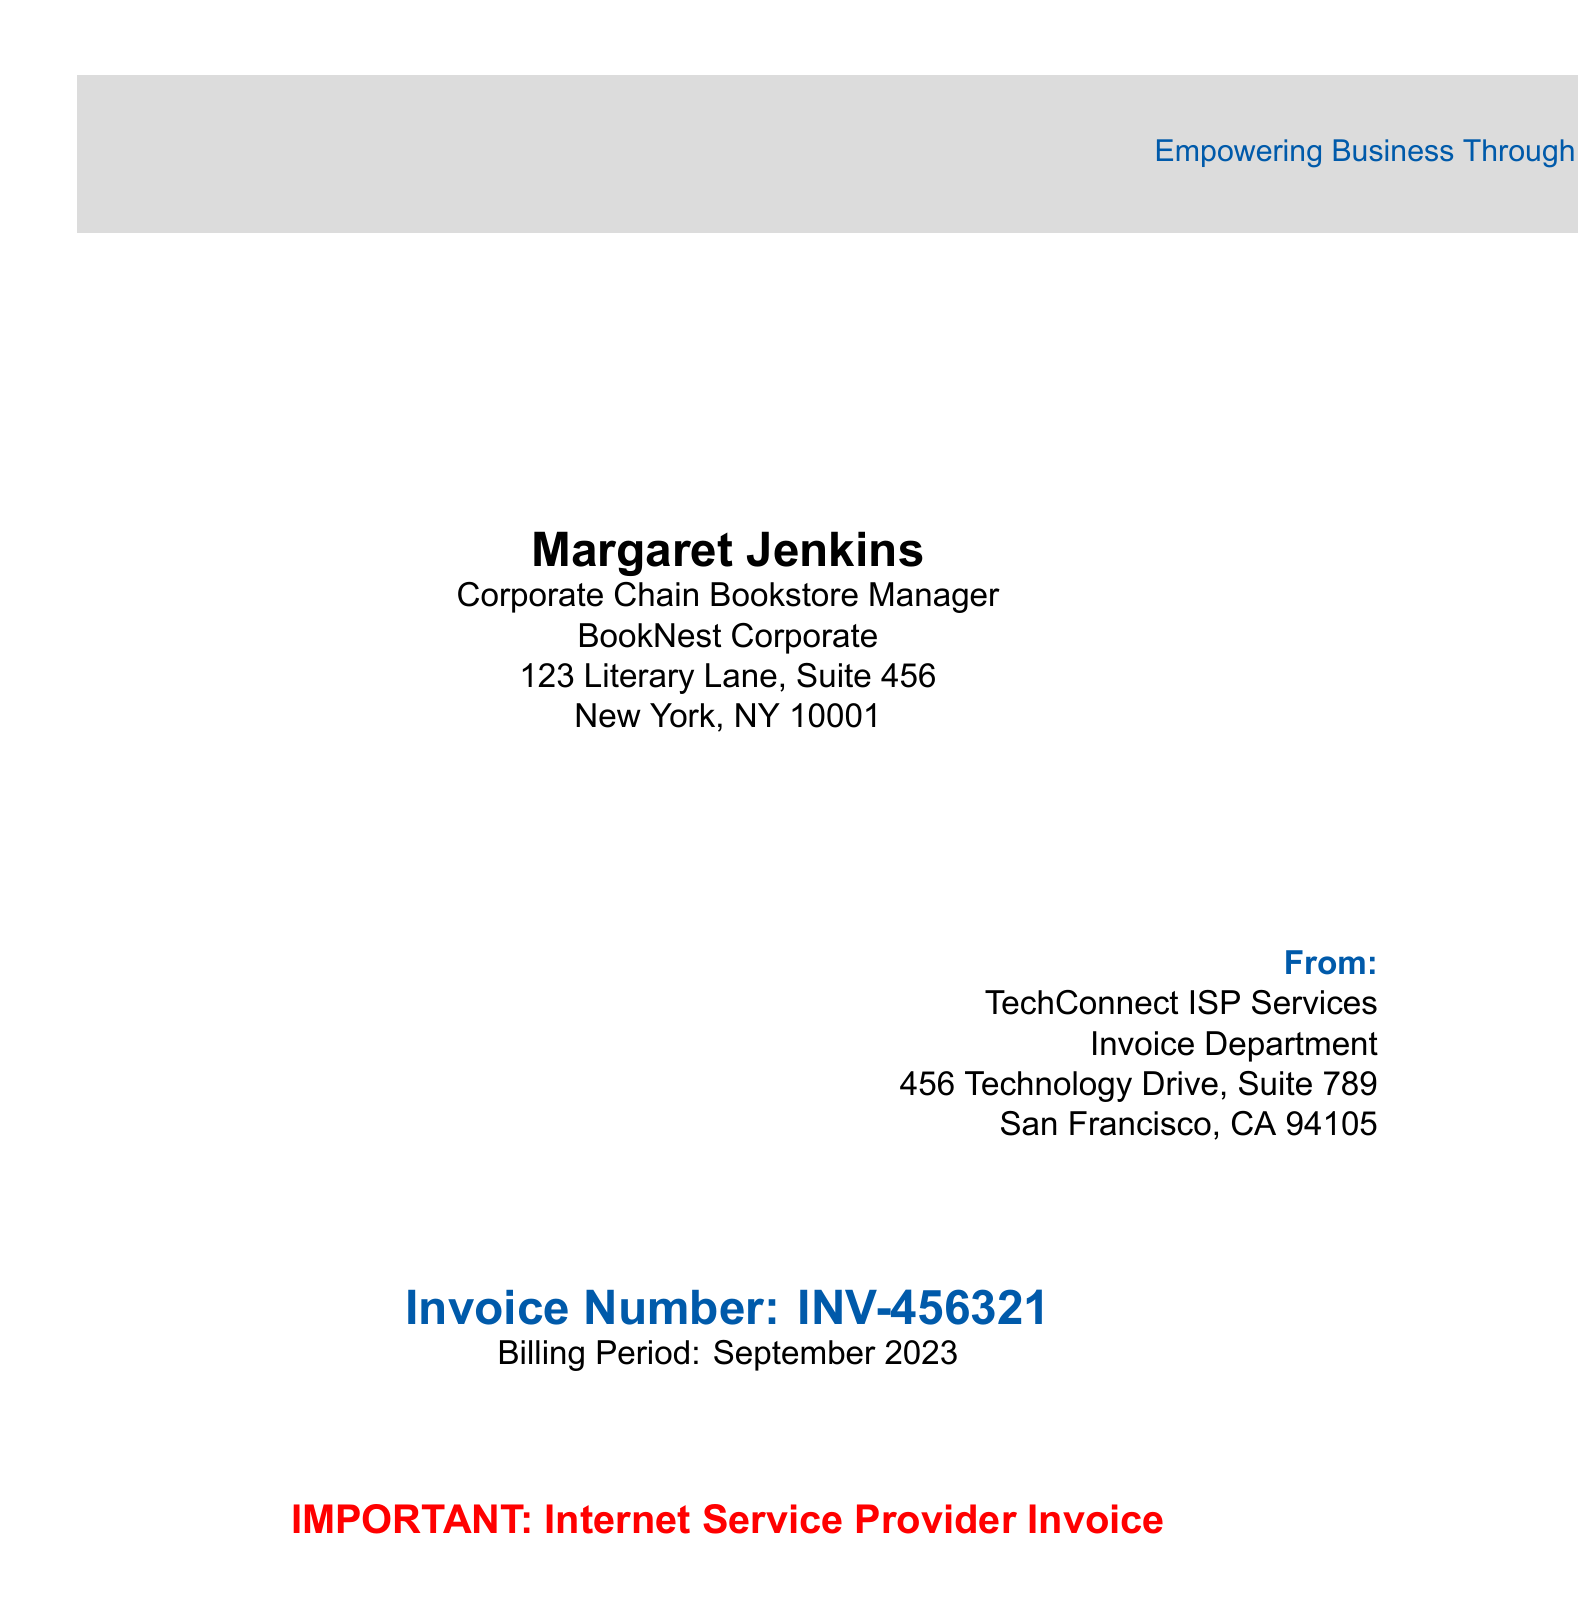What is the name of the manager? The manager's name is mentioned at the top of the document under the corporate bookstore details.
Answer: Margaret Jenkins What is the invoice number? The invoice number is a specific identifier for the bill, located near the center of the document.
Answer: INV-456321 Which month does this billing period cover? The billing period is clearly outlined under the invoice number in the document.
Answer: September 2023 What is the address of TechConnect ISP Services? The address of the service provider is listed in the contact section of the document.
Answer: 456 Technology Drive, Suite 789, San Francisco, CA 94105 Where is BookNest Corporate located? The location of the corporate bookstore is stated at the beginning under the bookstore manager's details.
Answer: 123 Literary Lane, Suite 456, New York, NY 10001 What is the tagline of TechConnect ISP Services? The tagline appears at the bottom of the document in the footer section.
Answer: Empowering Business Through Technology Who is the recipient of this invoice? The recipient's name and title are indicated at the top of the invoice details.
Answer: Margaret Jenkins What does the document signify as important? The document highlights a specific label about its nature towards the center.
Answer: Internet Service Provider Invoice 